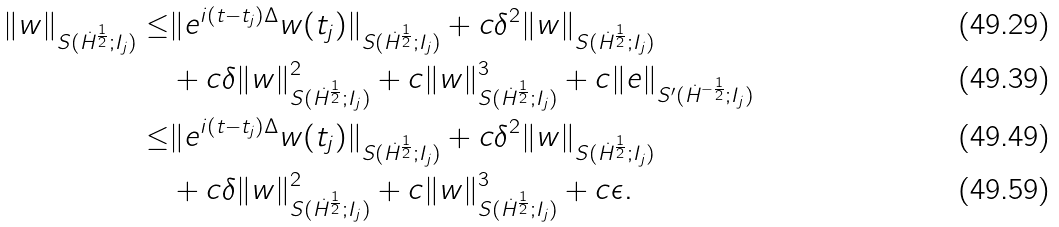<formula> <loc_0><loc_0><loc_500><loc_500>\| w \| _ { S ( \dot { H } ^ { \frac { 1 } { 2 } } ; I _ { j } ) } \leq & \| e ^ { i ( t - t _ { j } ) \Delta } w ( t _ { j } ) \| _ { S ( \dot { H } ^ { \frac { 1 } { 2 } } ; I _ { j } ) } + c \delta ^ { 2 } \| w \| _ { S ( \dot { H } ^ { \frac { 1 } { 2 } } ; I _ { j } ) } \\ & + c \delta \| w \| ^ { 2 } _ { S ( \dot { H } ^ { \frac { 1 } { 2 } } ; I _ { j } ) } + c \| w \| _ { S ( \dot { H } ^ { \frac { 1 } { 2 } } ; I _ { j } ) } ^ { 3 } + c \| e \| _ { S ^ { \prime } ( \dot { H } ^ { - \frac { 1 } { 2 } } ; I _ { j } ) } \\ \leq & \| e ^ { i ( t - t _ { j } ) \Delta } w ( t _ { j } ) \| _ { S ( \dot { H } ^ { \frac { 1 } { 2 } } ; I _ { j } ) } + c \delta ^ { 2 } \| w \| _ { S ( \dot { H } ^ { \frac { 1 } { 2 } } ; I _ { j } ) } \\ & + c \delta \| w \| ^ { 2 } _ { S ( \dot { H } ^ { \frac { 1 } { 2 } } ; I _ { j } ) } + c \| w \| _ { S ( \dot { H } ^ { \frac { 1 } { 2 } } ; I _ { j } ) } ^ { 3 } + c \epsilon .</formula> 